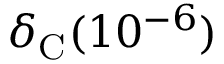Convert formula to latex. <formula><loc_0><loc_0><loc_500><loc_500>\delta _ { C } ( 1 0 ^ { - 6 } )</formula> 